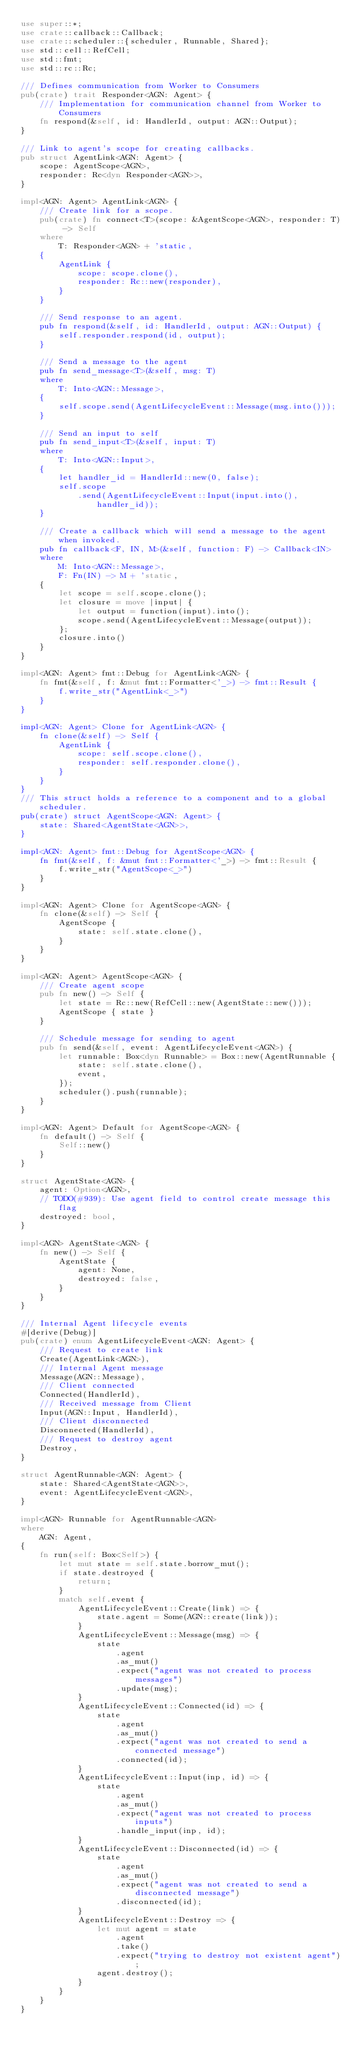Convert code to text. <code><loc_0><loc_0><loc_500><loc_500><_Rust_>use super::*;
use crate::callback::Callback;
use crate::scheduler::{scheduler, Runnable, Shared};
use std::cell::RefCell;
use std::fmt;
use std::rc::Rc;

/// Defines communication from Worker to Consumers
pub(crate) trait Responder<AGN: Agent> {
    /// Implementation for communication channel from Worker to Consumers
    fn respond(&self, id: HandlerId, output: AGN::Output);
}

/// Link to agent's scope for creating callbacks.
pub struct AgentLink<AGN: Agent> {
    scope: AgentScope<AGN>,
    responder: Rc<dyn Responder<AGN>>,
}

impl<AGN: Agent> AgentLink<AGN> {
    /// Create link for a scope.
    pub(crate) fn connect<T>(scope: &AgentScope<AGN>, responder: T) -> Self
    where
        T: Responder<AGN> + 'static,
    {
        AgentLink {
            scope: scope.clone(),
            responder: Rc::new(responder),
        }
    }

    /// Send response to an agent.
    pub fn respond(&self, id: HandlerId, output: AGN::Output) {
        self.responder.respond(id, output);
    }

    /// Send a message to the agent
    pub fn send_message<T>(&self, msg: T)
    where
        T: Into<AGN::Message>,
    {
        self.scope.send(AgentLifecycleEvent::Message(msg.into()));
    }

    /// Send an input to self
    pub fn send_input<T>(&self, input: T)
    where
        T: Into<AGN::Input>,
    {
        let handler_id = HandlerId::new(0, false);
        self.scope
            .send(AgentLifecycleEvent::Input(input.into(), handler_id));
    }

    /// Create a callback which will send a message to the agent when invoked.
    pub fn callback<F, IN, M>(&self, function: F) -> Callback<IN>
    where
        M: Into<AGN::Message>,
        F: Fn(IN) -> M + 'static,
    {
        let scope = self.scope.clone();
        let closure = move |input| {
            let output = function(input).into();
            scope.send(AgentLifecycleEvent::Message(output));
        };
        closure.into()
    }
}

impl<AGN: Agent> fmt::Debug for AgentLink<AGN> {
    fn fmt(&self, f: &mut fmt::Formatter<'_>) -> fmt::Result {
        f.write_str("AgentLink<_>")
    }
}

impl<AGN: Agent> Clone for AgentLink<AGN> {
    fn clone(&self) -> Self {
        AgentLink {
            scope: self.scope.clone(),
            responder: self.responder.clone(),
        }
    }
}
/// This struct holds a reference to a component and to a global scheduler.
pub(crate) struct AgentScope<AGN: Agent> {
    state: Shared<AgentState<AGN>>,
}

impl<AGN: Agent> fmt::Debug for AgentScope<AGN> {
    fn fmt(&self, f: &mut fmt::Formatter<'_>) -> fmt::Result {
        f.write_str("AgentScope<_>")
    }
}

impl<AGN: Agent> Clone for AgentScope<AGN> {
    fn clone(&self) -> Self {
        AgentScope {
            state: self.state.clone(),
        }
    }
}

impl<AGN: Agent> AgentScope<AGN> {
    /// Create agent scope
    pub fn new() -> Self {
        let state = Rc::new(RefCell::new(AgentState::new()));
        AgentScope { state }
    }

    /// Schedule message for sending to agent
    pub fn send(&self, event: AgentLifecycleEvent<AGN>) {
        let runnable: Box<dyn Runnable> = Box::new(AgentRunnable {
            state: self.state.clone(),
            event,
        });
        scheduler().push(runnable);
    }
}

impl<AGN: Agent> Default for AgentScope<AGN> {
    fn default() -> Self {
        Self::new()
    }
}

struct AgentState<AGN> {
    agent: Option<AGN>,
    // TODO(#939): Use agent field to control create message this flag
    destroyed: bool,
}

impl<AGN> AgentState<AGN> {
    fn new() -> Self {
        AgentState {
            agent: None,
            destroyed: false,
        }
    }
}

/// Internal Agent lifecycle events
#[derive(Debug)]
pub(crate) enum AgentLifecycleEvent<AGN: Agent> {
    /// Request to create link
    Create(AgentLink<AGN>),
    /// Internal Agent message
    Message(AGN::Message),
    /// Client connected
    Connected(HandlerId),
    /// Received message from Client
    Input(AGN::Input, HandlerId),
    /// Client disconnected
    Disconnected(HandlerId),
    /// Request to destroy agent
    Destroy,
}

struct AgentRunnable<AGN: Agent> {
    state: Shared<AgentState<AGN>>,
    event: AgentLifecycleEvent<AGN>,
}

impl<AGN> Runnable for AgentRunnable<AGN>
where
    AGN: Agent,
{
    fn run(self: Box<Self>) {
        let mut state = self.state.borrow_mut();
        if state.destroyed {
            return;
        }
        match self.event {
            AgentLifecycleEvent::Create(link) => {
                state.agent = Some(AGN::create(link));
            }
            AgentLifecycleEvent::Message(msg) => {
                state
                    .agent
                    .as_mut()
                    .expect("agent was not created to process messages")
                    .update(msg);
            }
            AgentLifecycleEvent::Connected(id) => {
                state
                    .agent
                    .as_mut()
                    .expect("agent was not created to send a connected message")
                    .connected(id);
            }
            AgentLifecycleEvent::Input(inp, id) => {
                state
                    .agent
                    .as_mut()
                    .expect("agent was not created to process inputs")
                    .handle_input(inp, id);
            }
            AgentLifecycleEvent::Disconnected(id) => {
                state
                    .agent
                    .as_mut()
                    .expect("agent was not created to send a disconnected message")
                    .disconnected(id);
            }
            AgentLifecycleEvent::Destroy => {
                let mut agent = state
                    .agent
                    .take()
                    .expect("trying to destroy not existent agent");
                agent.destroy();
            }
        }
    }
}
</code> 